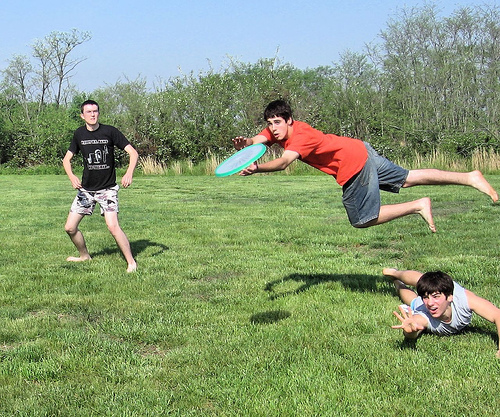What kind of day does it appear to be? It appears to be a sunny and clear day with bright light and blue skies. Can you create a story about what these boys might do after this game of frisbee? After an energetic game of frisbee, the boys decide to take a break and sit on the grass. They chat about their favorite moves and laugh about missed catches. Feeling a bit hungry, they head to a nearby ice cream stand and treat themselves to some refreshing ice cream cones. As they walk back home, they talk about planning another game soon and maybe even invite more friends to join. The day ends with them making plans for their next adventure, be it another frisbee game, a bike ride, or a simple picnic in the park. 